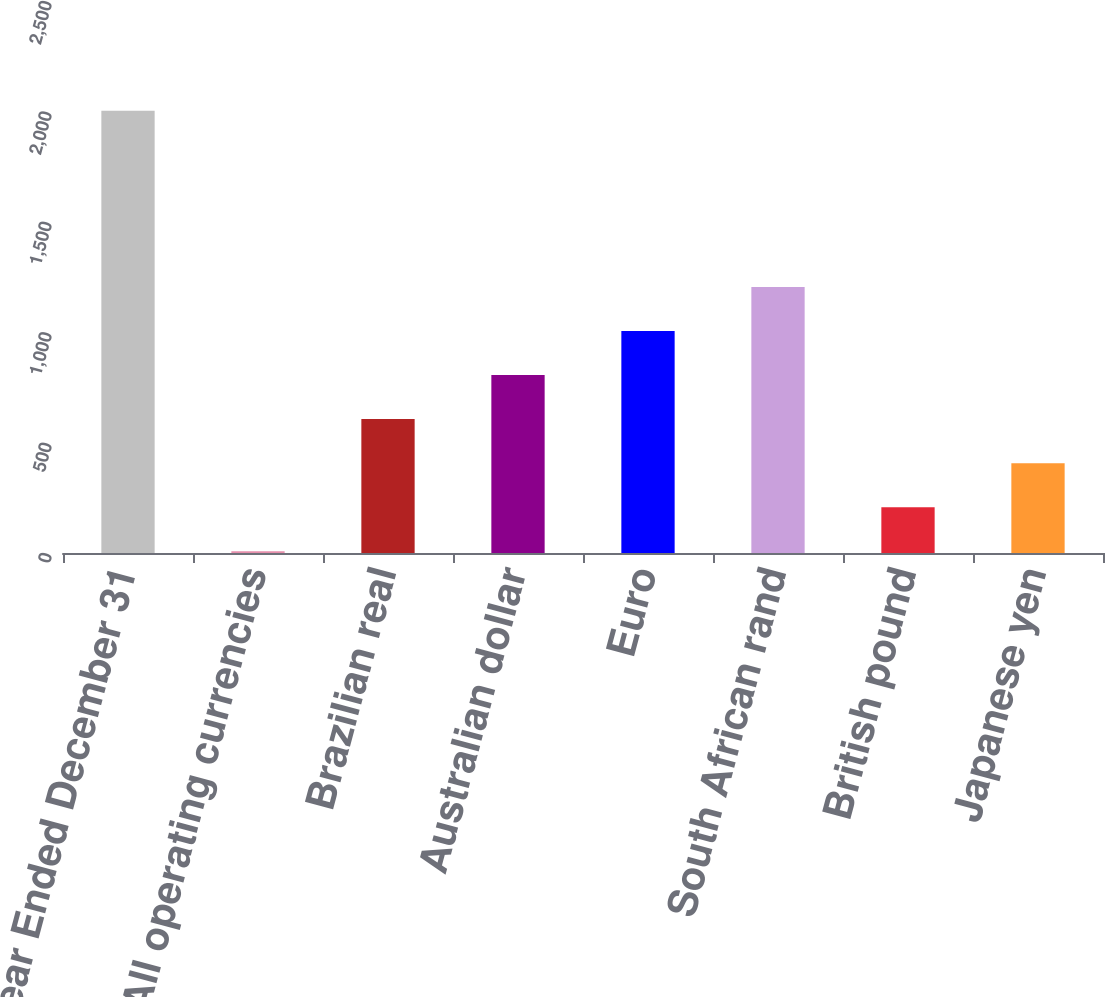Convert chart to OTSL. <chart><loc_0><loc_0><loc_500><loc_500><bar_chart><fcel>Year Ended December 31<fcel>All operating currencies<fcel>Brazilian real<fcel>Australian dollar<fcel>Euro<fcel>South African rand<fcel>British pound<fcel>Japanese yen<nl><fcel>2003<fcel>8<fcel>606.5<fcel>806<fcel>1005.5<fcel>1205<fcel>207.5<fcel>407<nl></chart> 